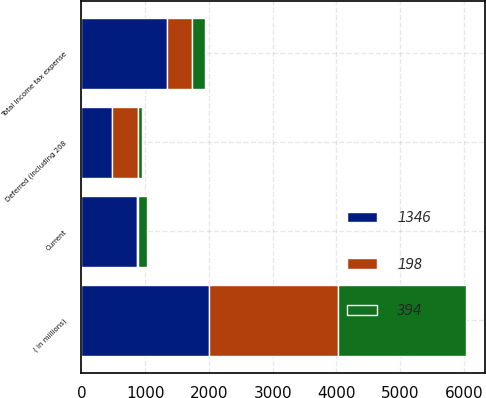Convert chart. <chart><loc_0><loc_0><loc_500><loc_500><stacked_bar_chart><ecel><fcel>( in millions)<fcel>Current<fcel>Deferred (including 208<fcel>Total income tax expense<nl><fcel>394<fcel>2010<fcel>133<fcel>65<fcel>198<nl><fcel>198<fcel>2009<fcel>18<fcel>412<fcel>394<nl><fcel>1346<fcel>2008<fcel>874<fcel>472<fcel>1346<nl></chart> 